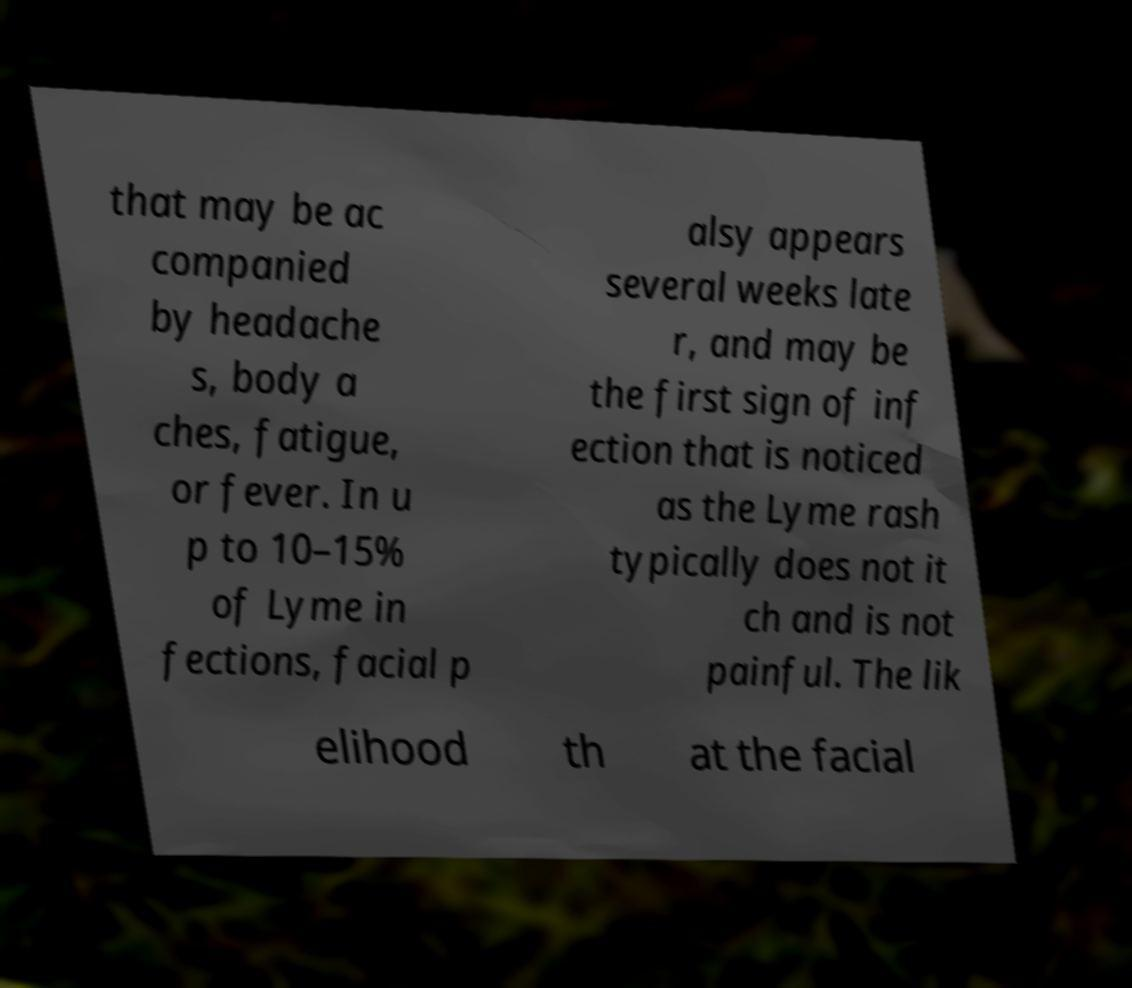For documentation purposes, I need the text within this image transcribed. Could you provide that? that may be ac companied by headache s, body a ches, fatigue, or fever. In u p to 10–15% of Lyme in fections, facial p alsy appears several weeks late r, and may be the first sign of inf ection that is noticed as the Lyme rash typically does not it ch and is not painful. The lik elihood th at the facial 